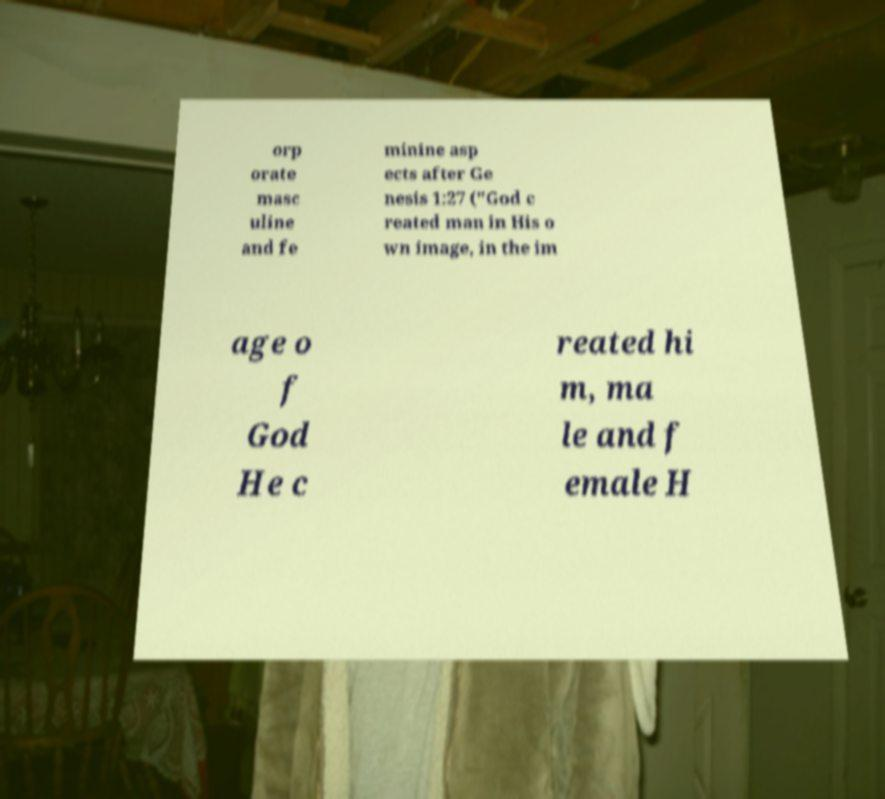Could you extract and type out the text from this image? orp orate masc uline and fe minine asp ects after Ge nesis 1:27 ("God c reated man in His o wn image, in the im age o f God He c reated hi m, ma le and f emale H 